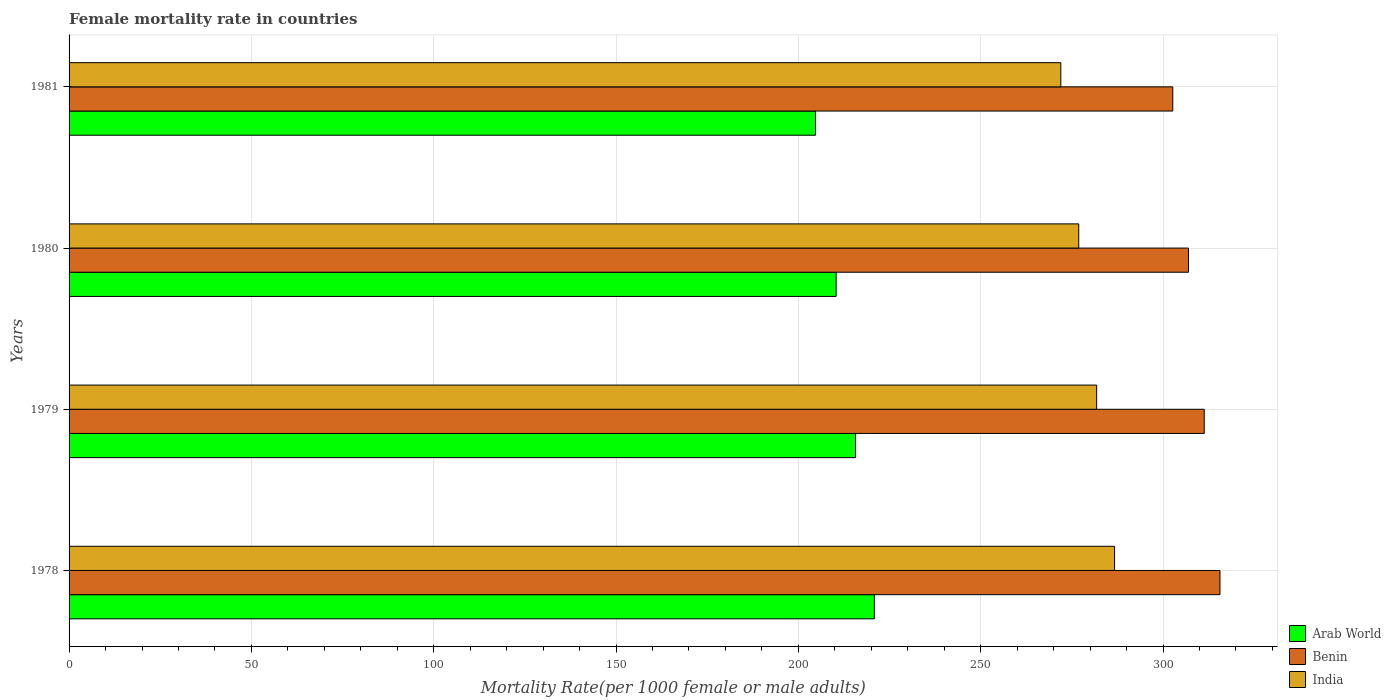How many different coloured bars are there?
Your answer should be compact. 3. Are the number of bars per tick equal to the number of legend labels?
Offer a very short reply. Yes. Are the number of bars on each tick of the Y-axis equal?
Your answer should be very brief. Yes. In how many cases, is the number of bars for a given year not equal to the number of legend labels?
Keep it short and to the point. 0. What is the female mortality rate in Benin in 1981?
Offer a very short reply. 302.67. Across all years, what is the maximum female mortality rate in India?
Give a very brief answer. 286.71. Across all years, what is the minimum female mortality rate in Arab World?
Your answer should be very brief. 204.71. In which year was the female mortality rate in Arab World maximum?
Offer a very short reply. 1978. In which year was the female mortality rate in Arab World minimum?
Give a very brief answer. 1981. What is the total female mortality rate in Benin in the graph?
Provide a succinct answer. 1236.55. What is the difference between the female mortality rate in India in 1978 and that in 1979?
Your answer should be very brief. 4.91. What is the difference between the female mortality rate in Benin in 1981 and the female mortality rate in India in 1978?
Your answer should be very brief. 15.96. What is the average female mortality rate in Benin per year?
Make the answer very short. 309.14. In the year 1978, what is the difference between the female mortality rate in Benin and female mortality rate in India?
Your answer should be compact. 28.9. In how many years, is the female mortality rate in India greater than 290 ?
Make the answer very short. 0. What is the ratio of the female mortality rate in Arab World in 1978 to that in 1980?
Ensure brevity in your answer.  1.05. What is the difference between the highest and the second highest female mortality rate in Arab World?
Your response must be concise. 5.17. What is the difference between the highest and the lowest female mortality rate in Arab World?
Offer a very short reply. 16.13. Is the sum of the female mortality rate in Benin in 1978 and 1981 greater than the maximum female mortality rate in India across all years?
Ensure brevity in your answer.  Yes. What does the 1st bar from the top in 1979 represents?
Keep it short and to the point. India. What does the 2nd bar from the bottom in 1979 represents?
Your answer should be compact. Benin. Is it the case that in every year, the sum of the female mortality rate in Benin and female mortality rate in India is greater than the female mortality rate in Arab World?
Your answer should be very brief. Yes. How many years are there in the graph?
Make the answer very short. 4. What is the difference between two consecutive major ticks on the X-axis?
Ensure brevity in your answer.  50. Does the graph contain any zero values?
Give a very brief answer. No. How are the legend labels stacked?
Ensure brevity in your answer.  Vertical. What is the title of the graph?
Provide a succinct answer. Female mortality rate in countries. What is the label or title of the X-axis?
Offer a very short reply. Mortality Rate(per 1000 female or male adults). What is the Mortality Rate(per 1000 female or male adults) of Arab World in 1978?
Offer a terse response. 220.84. What is the Mortality Rate(per 1000 female or male adults) in Benin in 1978?
Keep it short and to the point. 315.61. What is the Mortality Rate(per 1000 female or male adults) in India in 1978?
Make the answer very short. 286.71. What is the Mortality Rate(per 1000 female or male adults) of Arab World in 1979?
Offer a very short reply. 215.67. What is the Mortality Rate(per 1000 female or male adults) in Benin in 1979?
Give a very brief answer. 311.3. What is the Mortality Rate(per 1000 female or male adults) of India in 1979?
Make the answer very short. 281.79. What is the Mortality Rate(per 1000 female or male adults) in Arab World in 1980?
Keep it short and to the point. 210.35. What is the Mortality Rate(per 1000 female or male adults) of Benin in 1980?
Keep it short and to the point. 306.98. What is the Mortality Rate(per 1000 female or male adults) of India in 1980?
Provide a short and direct response. 276.88. What is the Mortality Rate(per 1000 female or male adults) of Arab World in 1981?
Offer a very short reply. 204.71. What is the Mortality Rate(per 1000 female or male adults) in Benin in 1981?
Offer a very short reply. 302.67. What is the Mortality Rate(per 1000 female or male adults) in India in 1981?
Provide a short and direct response. 271.97. Across all years, what is the maximum Mortality Rate(per 1000 female or male adults) of Arab World?
Keep it short and to the point. 220.84. Across all years, what is the maximum Mortality Rate(per 1000 female or male adults) of Benin?
Offer a very short reply. 315.61. Across all years, what is the maximum Mortality Rate(per 1000 female or male adults) of India?
Give a very brief answer. 286.71. Across all years, what is the minimum Mortality Rate(per 1000 female or male adults) of Arab World?
Your answer should be compact. 204.71. Across all years, what is the minimum Mortality Rate(per 1000 female or male adults) of Benin?
Your answer should be very brief. 302.67. Across all years, what is the minimum Mortality Rate(per 1000 female or male adults) in India?
Your answer should be compact. 271.97. What is the total Mortality Rate(per 1000 female or male adults) of Arab World in the graph?
Your response must be concise. 851.58. What is the total Mortality Rate(per 1000 female or male adults) in Benin in the graph?
Your answer should be very brief. 1236.55. What is the total Mortality Rate(per 1000 female or male adults) in India in the graph?
Your response must be concise. 1117.35. What is the difference between the Mortality Rate(per 1000 female or male adults) in Arab World in 1978 and that in 1979?
Make the answer very short. 5.17. What is the difference between the Mortality Rate(per 1000 female or male adults) of Benin in 1978 and that in 1979?
Give a very brief answer. 4.32. What is the difference between the Mortality Rate(per 1000 female or male adults) of India in 1978 and that in 1979?
Make the answer very short. 4.91. What is the difference between the Mortality Rate(per 1000 female or male adults) in Arab World in 1978 and that in 1980?
Provide a succinct answer. 10.49. What is the difference between the Mortality Rate(per 1000 female or male adults) in Benin in 1978 and that in 1980?
Offer a very short reply. 8.63. What is the difference between the Mortality Rate(per 1000 female or male adults) in India in 1978 and that in 1980?
Ensure brevity in your answer.  9.83. What is the difference between the Mortality Rate(per 1000 female or male adults) of Arab World in 1978 and that in 1981?
Your response must be concise. 16.13. What is the difference between the Mortality Rate(per 1000 female or male adults) of Benin in 1978 and that in 1981?
Your answer should be very brief. 12.95. What is the difference between the Mortality Rate(per 1000 female or male adults) in India in 1978 and that in 1981?
Your response must be concise. 14.74. What is the difference between the Mortality Rate(per 1000 female or male adults) of Arab World in 1979 and that in 1980?
Your answer should be compact. 5.33. What is the difference between the Mortality Rate(per 1000 female or male adults) of Benin in 1979 and that in 1980?
Your answer should be very brief. 4.32. What is the difference between the Mortality Rate(per 1000 female or male adults) of India in 1979 and that in 1980?
Your answer should be very brief. 4.91. What is the difference between the Mortality Rate(per 1000 female or male adults) in Arab World in 1979 and that in 1981?
Make the answer very short. 10.96. What is the difference between the Mortality Rate(per 1000 female or male adults) in Benin in 1979 and that in 1981?
Keep it short and to the point. 8.63. What is the difference between the Mortality Rate(per 1000 female or male adults) in India in 1979 and that in 1981?
Provide a short and direct response. 9.83. What is the difference between the Mortality Rate(per 1000 female or male adults) of Arab World in 1980 and that in 1981?
Ensure brevity in your answer.  5.64. What is the difference between the Mortality Rate(per 1000 female or male adults) of Benin in 1980 and that in 1981?
Make the answer very short. 4.32. What is the difference between the Mortality Rate(per 1000 female or male adults) of India in 1980 and that in 1981?
Ensure brevity in your answer.  4.91. What is the difference between the Mortality Rate(per 1000 female or male adults) in Arab World in 1978 and the Mortality Rate(per 1000 female or male adults) in Benin in 1979?
Your response must be concise. -90.45. What is the difference between the Mortality Rate(per 1000 female or male adults) of Arab World in 1978 and the Mortality Rate(per 1000 female or male adults) of India in 1979?
Provide a short and direct response. -60.95. What is the difference between the Mortality Rate(per 1000 female or male adults) in Benin in 1978 and the Mortality Rate(per 1000 female or male adults) in India in 1979?
Your response must be concise. 33.82. What is the difference between the Mortality Rate(per 1000 female or male adults) of Arab World in 1978 and the Mortality Rate(per 1000 female or male adults) of Benin in 1980?
Offer a terse response. -86.14. What is the difference between the Mortality Rate(per 1000 female or male adults) in Arab World in 1978 and the Mortality Rate(per 1000 female or male adults) in India in 1980?
Give a very brief answer. -56.04. What is the difference between the Mortality Rate(per 1000 female or male adults) in Benin in 1978 and the Mortality Rate(per 1000 female or male adults) in India in 1980?
Provide a succinct answer. 38.73. What is the difference between the Mortality Rate(per 1000 female or male adults) of Arab World in 1978 and the Mortality Rate(per 1000 female or male adults) of Benin in 1981?
Your answer should be very brief. -81.82. What is the difference between the Mortality Rate(per 1000 female or male adults) of Arab World in 1978 and the Mortality Rate(per 1000 female or male adults) of India in 1981?
Make the answer very short. -51.12. What is the difference between the Mortality Rate(per 1000 female or male adults) of Benin in 1978 and the Mortality Rate(per 1000 female or male adults) of India in 1981?
Make the answer very short. 43.65. What is the difference between the Mortality Rate(per 1000 female or male adults) in Arab World in 1979 and the Mortality Rate(per 1000 female or male adults) in Benin in 1980?
Your answer should be very brief. -91.31. What is the difference between the Mortality Rate(per 1000 female or male adults) of Arab World in 1979 and the Mortality Rate(per 1000 female or male adults) of India in 1980?
Offer a terse response. -61.21. What is the difference between the Mortality Rate(per 1000 female or male adults) in Benin in 1979 and the Mortality Rate(per 1000 female or male adults) in India in 1980?
Your response must be concise. 34.42. What is the difference between the Mortality Rate(per 1000 female or male adults) in Arab World in 1979 and the Mortality Rate(per 1000 female or male adults) in Benin in 1981?
Keep it short and to the point. -86.99. What is the difference between the Mortality Rate(per 1000 female or male adults) of Arab World in 1979 and the Mortality Rate(per 1000 female or male adults) of India in 1981?
Ensure brevity in your answer.  -56.29. What is the difference between the Mortality Rate(per 1000 female or male adults) of Benin in 1979 and the Mortality Rate(per 1000 female or male adults) of India in 1981?
Make the answer very short. 39.33. What is the difference between the Mortality Rate(per 1000 female or male adults) of Arab World in 1980 and the Mortality Rate(per 1000 female or male adults) of Benin in 1981?
Give a very brief answer. -92.32. What is the difference between the Mortality Rate(per 1000 female or male adults) in Arab World in 1980 and the Mortality Rate(per 1000 female or male adults) in India in 1981?
Provide a short and direct response. -61.62. What is the difference between the Mortality Rate(per 1000 female or male adults) in Benin in 1980 and the Mortality Rate(per 1000 female or male adults) in India in 1981?
Your answer should be compact. 35.02. What is the average Mortality Rate(per 1000 female or male adults) of Arab World per year?
Your answer should be compact. 212.89. What is the average Mortality Rate(per 1000 female or male adults) of Benin per year?
Offer a very short reply. 309.14. What is the average Mortality Rate(per 1000 female or male adults) in India per year?
Offer a terse response. 279.34. In the year 1978, what is the difference between the Mortality Rate(per 1000 female or male adults) of Arab World and Mortality Rate(per 1000 female or male adults) of Benin?
Offer a very short reply. -94.77. In the year 1978, what is the difference between the Mortality Rate(per 1000 female or male adults) of Arab World and Mortality Rate(per 1000 female or male adults) of India?
Provide a short and direct response. -65.86. In the year 1978, what is the difference between the Mortality Rate(per 1000 female or male adults) in Benin and Mortality Rate(per 1000 female or male adults) in India?
Provide a succinct answer. 28.91. In the year 1979, what is the difference between the Mortality Rate(per 1000 female or male adults) in Arab World and Mortality Rate(per 1000 female or male adults) in Benin?
Ensure brevity in your answer.  -95.62. In the year 1979, what is the difference between the Mortality Rate(per 1000 female or male adults) of Arab World and Mortality Rate(per 1000 female or male adults) of India?
Provide a short and direct response. -66.12. In the year 1979, what is the difference between the Mortality Rate(per 1000 female or male adults) in Benin and Mortality Rate(per 1000 female or male adults) in India?
Offer a very short reply. 29.5. In the year 1980, what is the difference between the Mortality Rate(per 1000 female or male adults) in Arab World and Mortality Rate(per 1000 female or male adults) in Benin?
Keep it short and to the point. -96.63. In the year 1980, what is the difference between the Mortality Rate(per 1000 female or male adults) of Arab World and Mortality Rate(per 1000 female or male adults) of India?
Your answer should be very brief. -66.53. In the year 1980, what is the difference between the Mortality Rate(per 1000 female or male adults) in Benin and Mortality Rate(per 1000 female or male adults) in India?
Your response must be concise. 30.1. In the year 1981, what is the difference between the Mortality Rate(per 1000 female or male adults) in Arab World and Mortality Rate(per 1000 female or male adults) in Benin?
Your answer should be very brief. -97.95. In the year 1981, what is the difference between the Mortality Rate(per 1000 female or male adults) of Arab World and Mortality Rate(per 1000 female or male adults) of India?
Provide a succinct answer. -67.25. In the year 1981, what is the difference between the Mortality Rate(per 1000 female or male adults) in Benin and Mortality Rate(per 1000 female or male adults) in India?
Give a very brief answer. 30.7. What is the ratio of the Mortality Rate(per 1000 female or male adults) in Arab World in 1978 to that in 1979?
Your answer should be compact. 1.02. What is the ratio of the Mortality Rate(per 1000 female or male adults) in Benin in 1978 to that in 1979?
Your answer should be compact. 1.01. What is the ratio of the Mortality Rate(per 1000 female or male adults) of India in 1978 to that in 1979?
Provide a short and direct response. 1.02. What is the ratio of the Mortality Rate(per 1000 female or male adults) of Arab World in 1978 to that in 1980?
Your response must be concise. 1.05. What is the ratio of the Mortality Rate(per 1000 female or male adults) of Benin in 1978 to that in 1980?
Offer a very short reply. 1.03. What is the ratio of the Mortality Rate(per 1000 female or male adults) in India in 1978 to that in 1980?
Your answer should be compact. 1.04. What is the ratio of the Mortality Rate(per 1000 female or male adults) of Arab World in 1978 to that in 1981?
Offer a terse response. 1.08. What is the ratio of the Mortality Rate(per 1000 female or male adults) of Benin in 1978 to that in 1981?
Your answer should be compact. 1.04. What is the ratio of the Mortality Rate(per 1000 female or male adults) of India in 1978 to that in 1981?
Provide a succinct answer. 1.05. What is the ratio of the Mortality Rate(per 1000 female or male adults) of Arab World in 1979 to that in 1980?
Give a very brief answer. 1.03. What is the ratio of the Mortality Rate(per 1000 female or male adults) of Benin in 1979 to that in 1980?
Your answer should be compact. 1.01. What is the ratio of the Mortality Rate(per 1000 female or male adults) of India in 1979 to that in 1980?
Provide a short and direct response. 1.02. What is the ratio of the Mortality Rate(per 1000 female or male adults) in Arab World in 1979 to that in 1981?
Your answer should be very brief. 1.05. What is the ratio of the Mortality Rate(per 1000 female or male adults) of Benin in 1979 to that in 1981?
Provide a short and direct response. 1.03. What is the ratio of the Mortality Rate(per 1000 female or male adults) in India in 1979 to that in 1981?
Give a very brief answer. 1.04. What is the ratio of the Mortality Rate(per 1000 female or male adults) in Arab World in 1980 to that in 1981?
Your answer should be very brief. 1.03. What is the ratio of the Mortality Rate(per 1000 female or male adults) of Benin in 1980 to that in 1981?
Offer a terse response. 1.01. What is the ratio of the Mortality Rate(per 1000 female or male adults) in India in 1980 to that in 1981?
Provide a succinct answer. 1.02. What is the difference between the highest and the second highest Mortality Rate(per 1000 female or male adults) in Arab World?
Give a very brief answer. 5.17. What is the difference between the highest and the second highest Mortality Rate(per 1000 female or male adults) in Benin?
Offer a terse response. 4.32. What is the difference between the highest and the second highest Mortality Rate(per 1000 female or male adults) in India?
Offer a very short reply. 4.91. What is the difference between the highest and the lowest Mortality Rate(per 1000 female or male adults) of Arab World?
Your answer should be compact. 16.13. What is the difference between the highest and the lowest Mortality Rate(per 1000 female or male adults) in Benin?
Give a very brief answer. 12.95. What is the difference between the highest and the lowest Mortality Rate(per 1000 female or male adults) in India?
Your response must be concise. 14.74. 